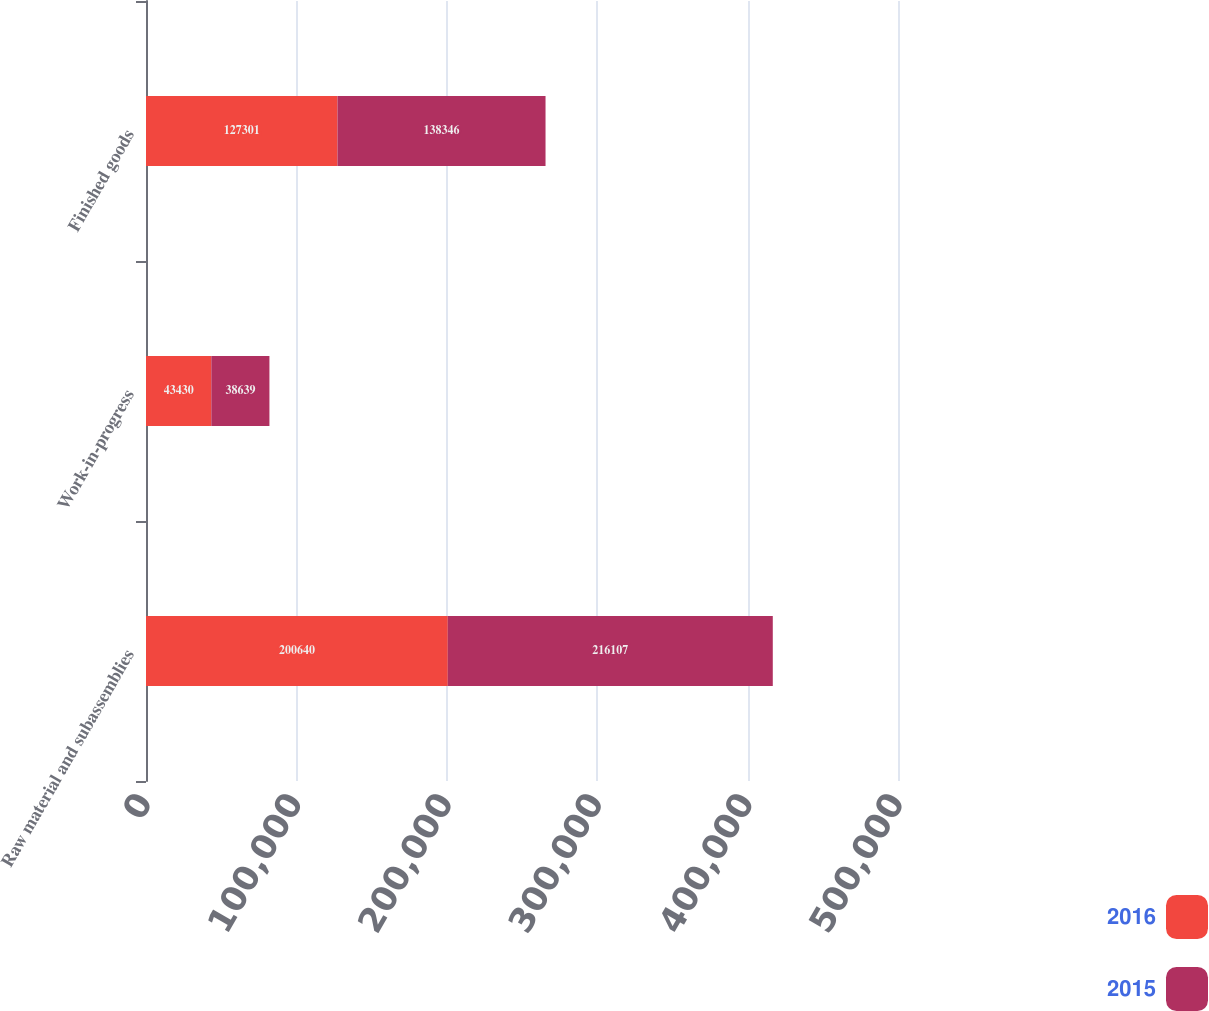Convert chart. <chart><loc_0><loc_0><loc_500><loc_500><stacked_bar_chart><ecel><fcel>Raw material and subassemblies<fcel>Work-in-progress<fcel>Finished goods<nl><fcel>2016<fcel>200640<fcel>43430<fcel>127301<nl><fcel>2015<fcel>216107<fcel>38639<fcel>138346<nl></chart> 